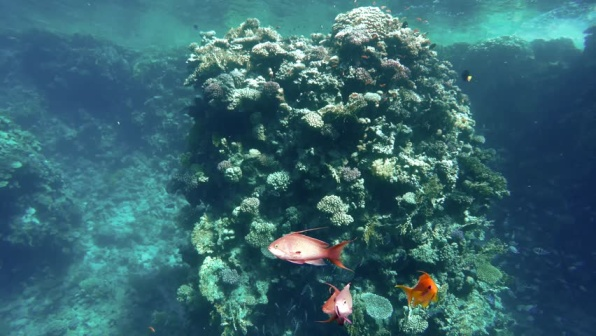What other marine creatures could be found around this coral reef, beyond what is visible in the image? While the image highlights a few species of fish and various types of coral, a coral reef ecosystem such as this one would host a rich diversity of marine life. Beyond what is visible, one might find sea turtles gracefully gliding through the water, feeding on seagrass or resting on the reef. Sharks and rays could also be present, patrolling the waters for prey.

In the nooks and crannies of the coral itself, one could discover a myriad of smaller, less conspicuous creatures such as shrimp, crabs, and various mollusks. Octopuses might also be found, camouflaging themselves amongst the coral, waiting to ambush their prey. Schools of smaller fish, like anthias and clownfish, could be seen darting in and out of the coral branches, while various types of eels might be spotted peering out from crevices.

The reef would also be home to an immense variety of invertebrates, including sponges, sea stars, and sea urchins, each playing a unique role in the ecosystem. The biodiversity of a coral reef is immense, with every species contributing to the intricate balance and health of this underwater world. Create a short story about a day in the life of an orange fish in this coral reef. In the vibrant coral reef, an orange fish named Flick awoke with the first light of dawn filtering through the water. Flick darted from his cozy coral nook, ready to explore the bustling underwater city. The reef was alive with activity as he joined a school of fish, weaving through the coral structures, searching for plankton.

As he swam, Flick spotted his friend, Bubbles the cleaner shrimp, busy at work on a large brain coral. Flick paused for a quick cleaning, enjoying the ticklish sensation as Bubbles nibbled away parasites. Rejuvenated, Flick continued his journey, marvelling at the array of colors and creatures around him.

Around midday, he encountered a group of playful dolphins that visited the reef. They swooped and swirled around Flick, inviting him to join their game. Despite their size, the dolphins were gentle, and Flick relished the excitement of their high-speed chase.

In the afternoon, Flick discovered a hidden cave filled with delicacies. He feasted on tiny shrimp and algae, filling his belly. As the sun set, casting a golden glow over the reef, Flick returned to his coral home, tired but content. He watched the reef's nocturnal creatures emerge, with the bioluminescent glow illuminating the night.

Finally, Flick settled into his nook, reflecting on the day's adventures before drifting off to sleep, looking forward to another day in his wondrous coral reef home. How might global warming affect the vibrant coral reef seen in the image? Global warming poses a significant threat to the vibrant coral reef depicted in the image. Rising sea temperatures can cause coral bleaching, a phenomenon where the symbiotic algae living within the coral tissues are expelled. This leaves the coral with a stark white appearance and severely reduces its ability to produce energy through photosynthesis. Prolonged bleaching can lead to the death of coral colonies, drastically reducing the biodiversity and structural complexity of the reef.

Additionally, increased levels of carbon dioxide in the atmosphere lead to ocean acidification, which weakens the coral skeletons and makes it harder for new coral to grow. This can result in a more fragile reef structure that is less resilient to physical damage and storms.

Global warming also affects the overall health of the marine ecosystem. Changes in water temperature and chemistry can disrupt the spawning cycles of fish and other marine organisms, leading to declines in population. The loss of coral habitat further exacerbates this issue, as many species rely on the reef for shelter, breeding grounds, and food sources.

The reduction in biodiversity and the degradation of the reef's structure can have far-reaching impacts on the entire marine ecosystem, including the human communities that depend on healthy reef systems for their livelihoods through fishing, tourism, and coastal protection. Addressing global warming and its effects is crucial to preserving the beauty and vitality of coral reefs worldwide. For a playful twist, what would happen if the coral reef suddenly gained the ability to speak? Create a conversation between the reef and one of the fish. Fish (Flick): *swimming around* "Hey, Coral! How's it going today?" 

Coral Reef: "Well, hello there, Flick! It's a fine day in our underwater world, isn't it?" 

Flick: "Absolutely! I was just thinking about how amazing it is here. All the different colors and creatures... it's like a never-ending party!" 

Coral Reef (laughing gently): "Indeed, Flick. Every day is bustling with life and activity. Though we must always be vigilant to keep our ecosystem in balance." 

Flick: "I heard from Bubbles the shrimp that there's some new algae growing on your east side. Should I help clean it up?" 

Coral Reef: "That would be wonderful, Flick. Teamwork is what keeps our community thriving. Perhaps you could invite more of your friends to join in?" 

Flick: "Sure thing! And you know, Coral, I've always wondered... what's your secret to growing so strong and beautiful?" 

Coral Reef: "Why, Flick, it's all about the relationships we build. The symbiotic algae give me nourishment, the fish keep pests at bay, and together, we create a harmonious environment. It's the power of collaboration, my dear friend." 

Flick: "That's so inspiring, Coral. I'm glad we have each other. Now, let's gather some friends and get to that algae!" 

Coral Reef: "Thank you, Flick. Let's make our home even more magnificent." 